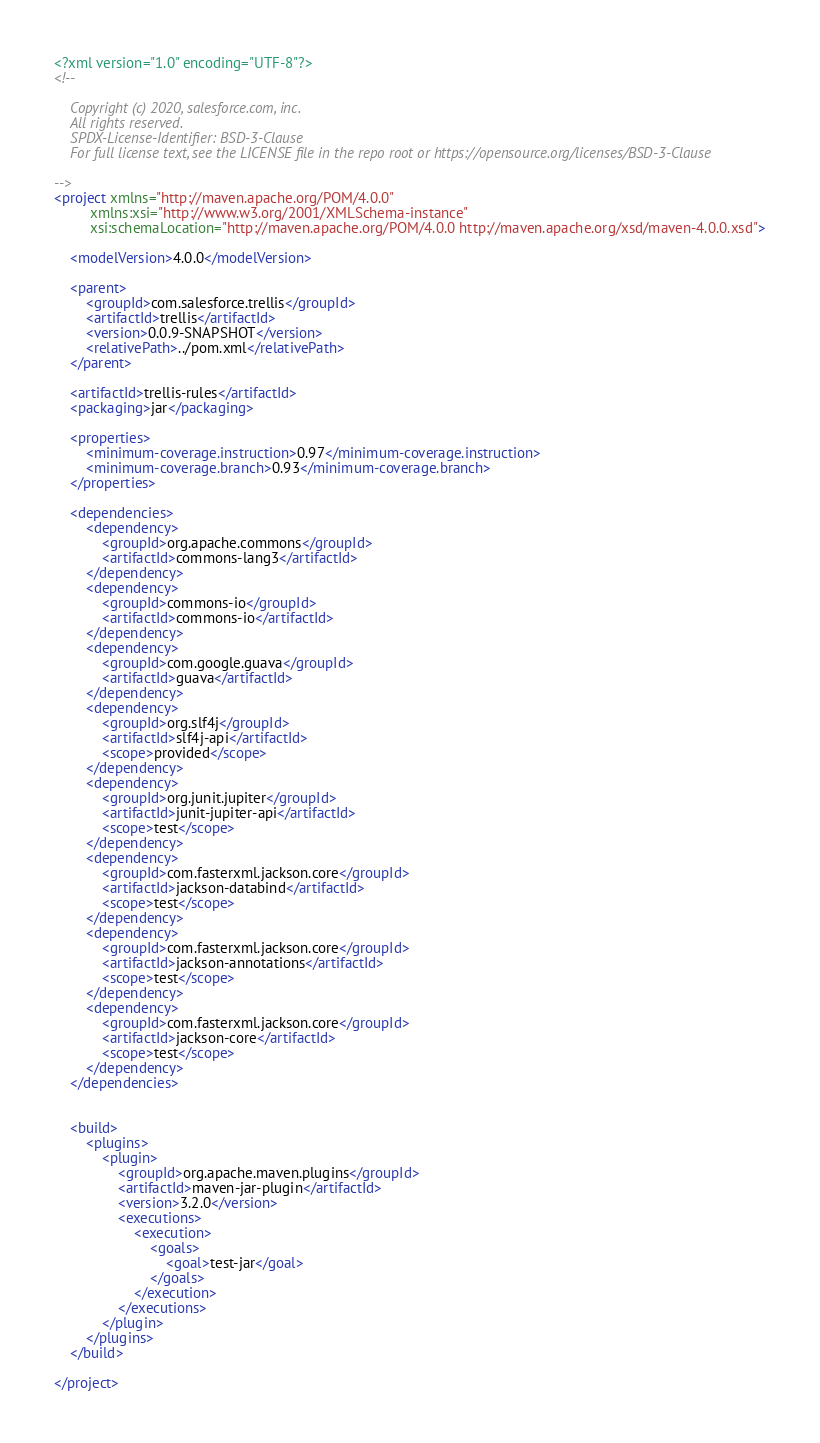Convert code to text. <code><loc_0><loc_0><loc_500><loc_500><_XML_><?xml version="1.0" encoding="UTF-8"?>
<!--

    Copyright (c) 2020, salesforce.com, inc.
    All rights reserved.
    SPDX-License-Identifier: BSD-3-Clause
    For full license text, see the LICENSE file in the repo root or https://opensource.org/licenses/BSD-3-Clause

-->
<project xmlns="http://maven.apache.org/POM/4.0.0"
         xmlns:xsi="http://www.w3.org/2001/XMLSchema-instance"
         xsi:schemaLocation="http://maven.apache.org/POM/4.0.0 http://maven.apache.org/xsd/maven-4.0.0.xsd">

    <modelVersion>4.0.0</modelVersion>

    <parent>
        <groupId>com.salesforce.trellis</groupId>
        <artifactId>trellis</artifactId>
        <version>0.0.9-SNAPSHOT</version>
        <relativePath>../pom.xml</relativePath>
    </parent>

    <artifactId>trellis-rules</artifactId>
    <packaging>jar</packaging>

    <properties>
        <minimum-coverage.instruction>0.97</minimum-coverage.instruction>
        <minimum-coverage.branch>0.93</minimum-coverage.branch>
    </properties>

    <dependencies>
        <dependency>
            <groupId>org.apache.commons</groupId>
            <artifactId>commons-lang3</artifactId>
        </dependency>
        <dependency>
            <groupId>commons-io</groupId>
            <artifactId>commons-io</artifactId>
        </dependency>
        <dependency>
            <groupId>com.google.guava</groupId>
            <artifactId>guava</artifactId>
        </dependency>
        <dependency>
            <groupId>org.slf4j</groupId>
            <artifactId>slf4j-api</artifactId>
            <scope>provided</scope>
        </dependency>
        <dependency>
            <groupId>org.junit.jupiter</groupId>
            <artifactId>junit-jupiter-api</artifactId>
            <scope>test</scope>
        </dependency>
        <dependency>
            <groupId>com.fasterxml.jackson.core</groupId>
            <artifactId>jackson-databind</artifactId>
            <scope>test</scope>
        </dependency>
        <dependency>
            <groupId>com.fasterxml.jackson.core</groupId>
            <artifactId>jackson-annotations</artifactId>
            <scope>test</scope>
        </dependency>
        <dependency>
            <groupId>com.fasterxml.jackson.core</groupId>
            <artifactId>jackson-core</artifactId>
            <scope>test</scope>
        </dependency>
    </dependencies>


    <build>
        <plugins>
            <plugin>
                <groupId>org.apache.maven.plugins</groupId>
                <artifactId>maven-jar-plugin</artifactId>
                <version>3.2.0</version>
                <executions>
                    <execution>
                        <goals>
                            <goal>test-jar</goal>
                        </goals>
                    </execution>
                </executions>
            </plugin>
        </plugins>
    </build>

</project>
</code> 